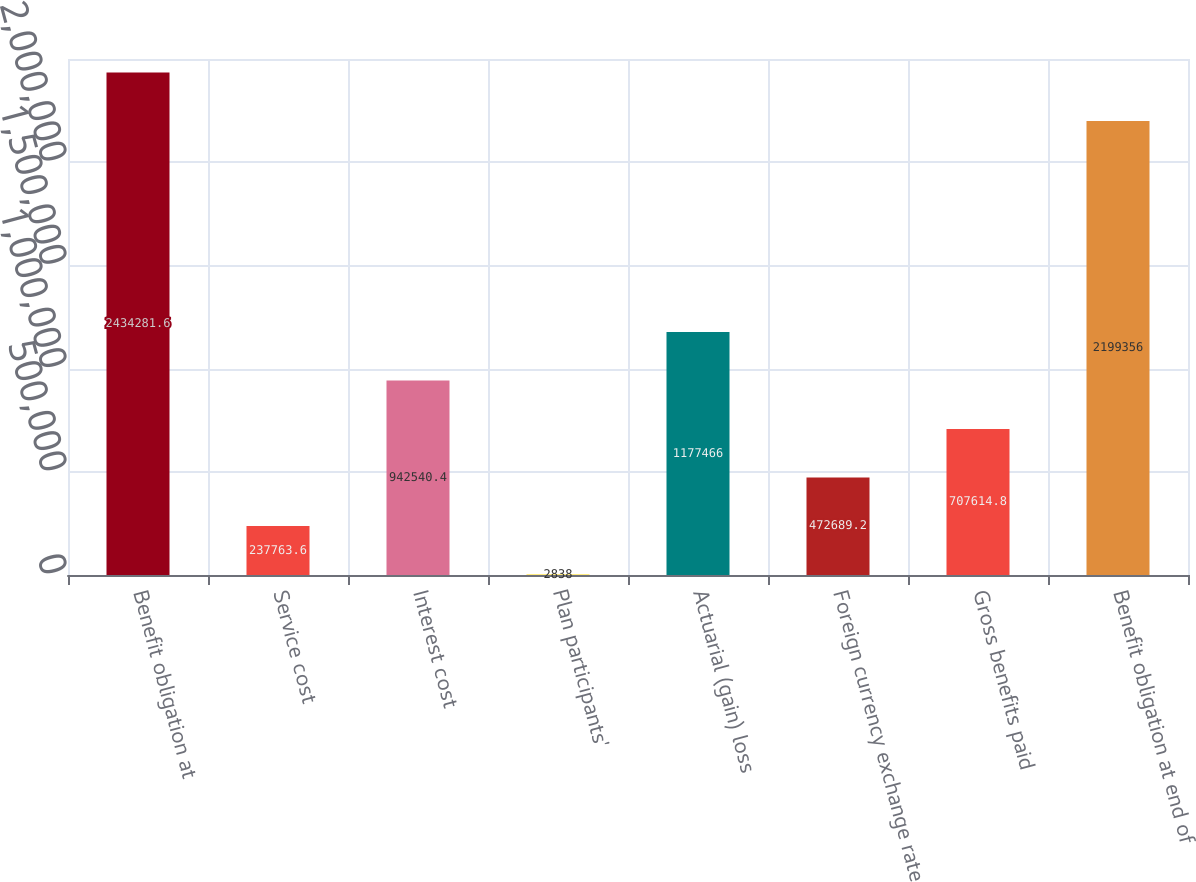<chart> <loc_0><loc_0><loc_500><loc_500><bar_chart><fcel>Benefit obligation at<fcel>Service cost<fcel>Interest cost<fcel>Plan participants'<fcel>Actuarial (gain) loss<fcel>Foreign currency exchange rate<fcel>Gross benefits paid<fcel>Benefit obligation at end of<nl><fcel>2.43428e+06<fcel>237764<fcel>942540<fcel>2838<fcel>1.17747e+06<fcel>472689<fcel>707615<fcel>2.19936e+06<nl></chart> 